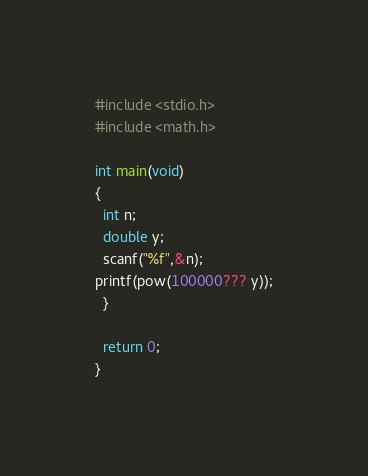Convert code to text. <code><loc_0><loc_0><loc_500><loc_500><_C_>#include <stdio.h>
#include <math.h>

int main(void)
{
  int n;
  double y;
  scanf("%f",&n);
printf(pow(100000??? y));
  }

  return 0;
}</code> 